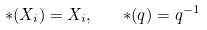<formula> <loc_0><loc_0><loc_500><loc_500>\ast ( X _ { i } ) = X _ { i } , \quad \ast ( q ) = q ^ { - 1 }</formula> 